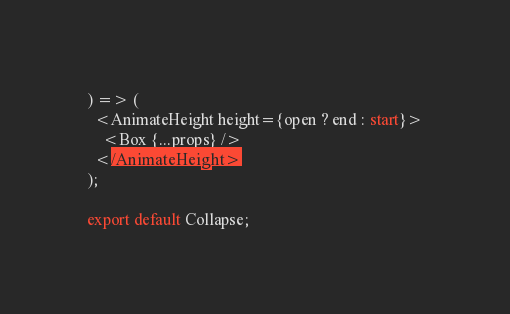<code> <loc_0><loc_0><loc_500><loc_500><_TypeScript_>) => (
  <AnimateHeight height={open ? end : start}>
    <Box {...props} />
  </AnimateHeight>
);

export default Collapse;
</code> 